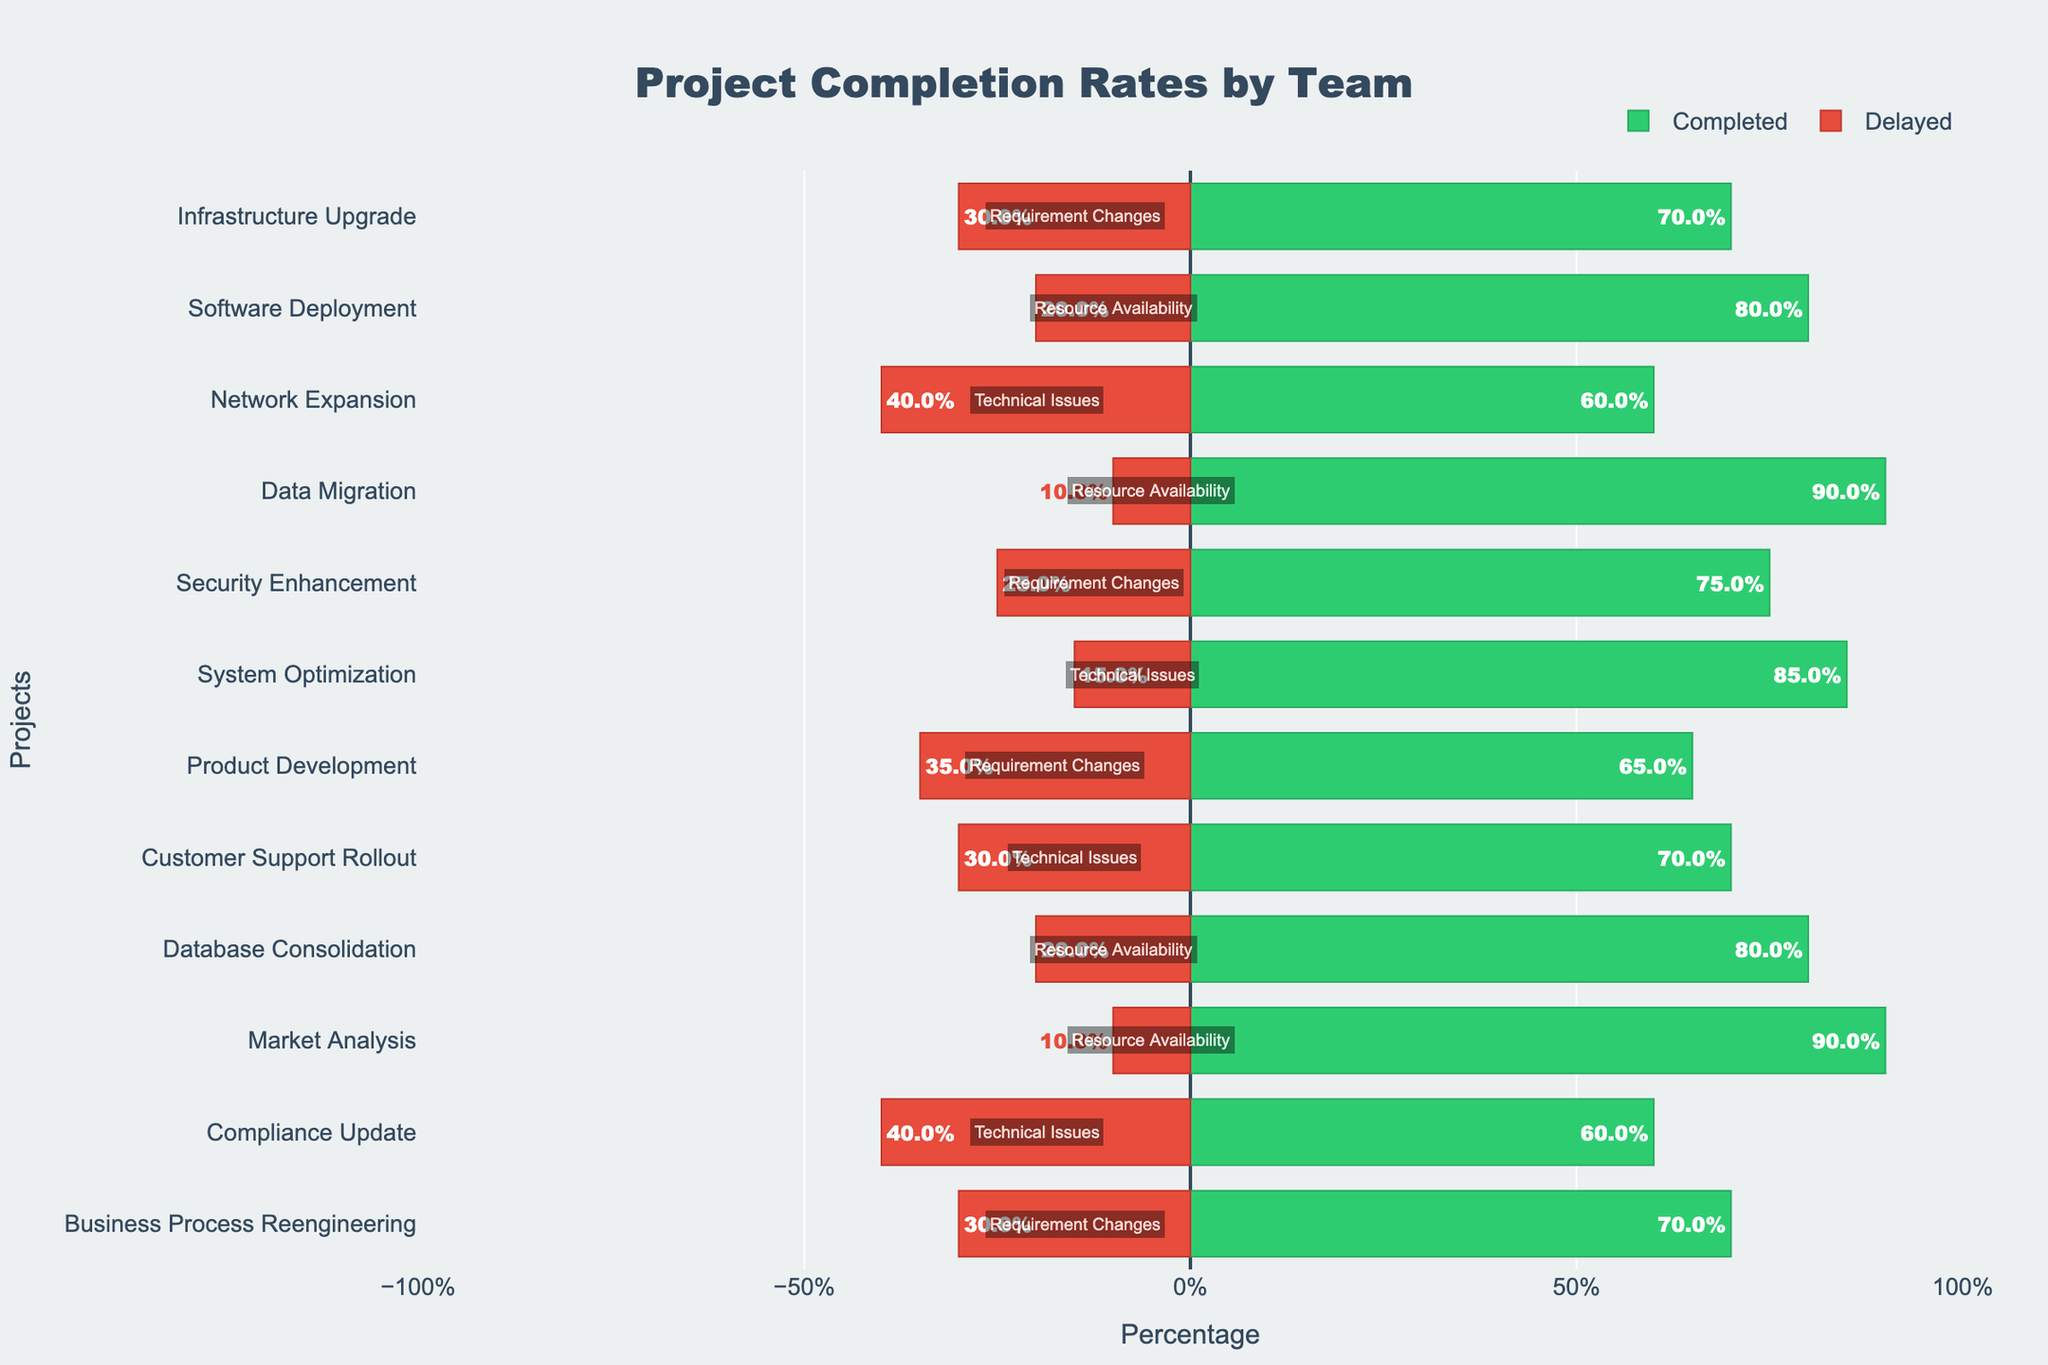How many projects in Team Alpha have more than 30% delay? To find this, we need to look at the delayed percentages for each project in Team Alpha. The projects and their delays are: Infrastructure Upgrade (30%), Software Deployment (20%), and Network Expansion (40%). Only Network Expansion has more than 30% delay.
Answer: 1 Which team has the least percentage of completion for any project? By looking at the green bars (completed percentage) for each team, the lowest completion rate should be identified. Delta's Compliance Update has the lowest completion at 60%.
Answer: Delta Which project within team Beta has the highest delay percentage, and what is the reason for the delay? We need to compare the red bars (delay percentage) within Team Beta. The delays are: Data Migration (10%), Security Enhancement (25%), and System Optimization (15%). Security Enhancement has the highest delay at 25%. The reason for the delay is "Requirement Changes".
Answer: Security Enhancement, Requirement Changes What is the total percentage of completion for Team Gamma's projects? We need to sum the completion percentages for Team Gamma’s projects: Product Development (65%), Customer Support Rollout (70%), and Database Consolidation (80%). So, the total completion is 65% + 70% + 80% = 215%.
Answer: 215% Compare the delay percentages for Data Migration and Compliance Update. Which project has a higher delay and by how much? Data Migration has a delay of 10%, and Compliance Update has a delay of 40%. The difference is 40% - 10% = 30%. Compliance Update has a higher delay by 30%.
Answer: Compliance Update, 30% 